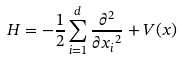<formula> <loc_0><loc_0><loc_500><loc_500>H = - \frac { 1 } { 2 } \sum _ { i = 1 } ^ { d } \frac { { \partial } ^ { 2 } } { \partial { x _ { i } } ^ { 2 } } + V ( x )</formula> 